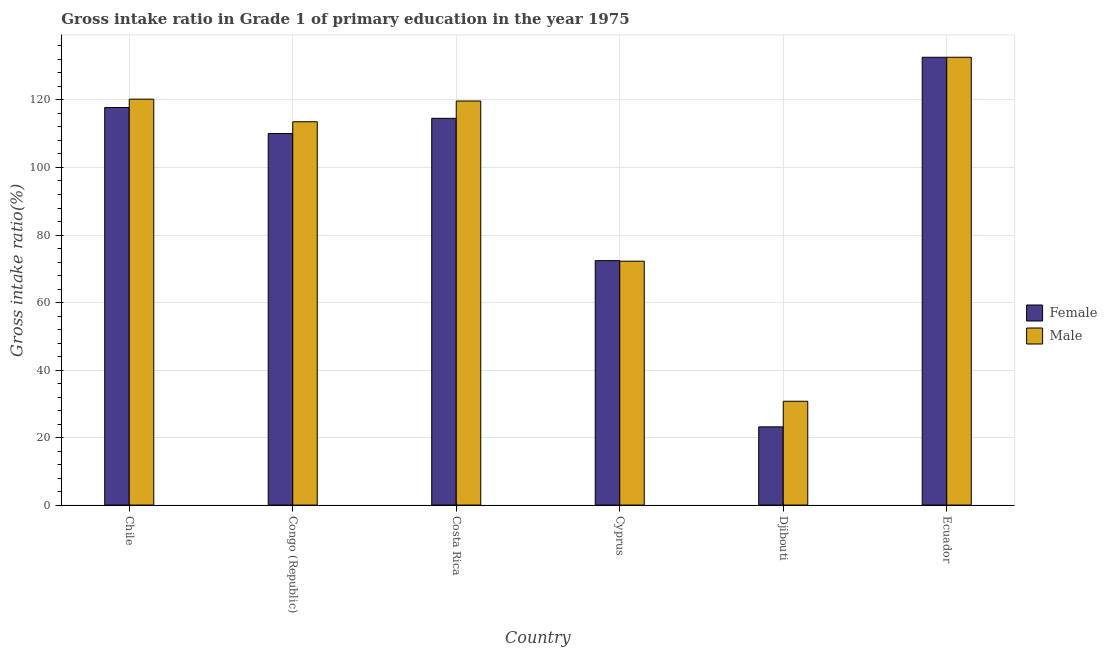How many bars are there on the 4th tick from the left?
Give a very brief answer. 2. How many bars are there on the 3rd tick from the right?
Your answer should be very brief. 2. What is the label of the 6th group of bars from the left?
Give a very brief answer. Ecuador. In how many cases, is the number of bars for a given country not equal to the number of legend labels?
Offer a terse response. 0. What is the gross intake ratio(male) in Djibouti?
Provide a succinct answer. 30.76. Across all countries, what is the maximum gross intake ratio(female)?
Your answer should be compact. 132.65. Across all countries, what is the minimum gross intake ratio(male)?
Offer a very short reply. 30.76. In which country was the gross intake ratio(male) maximum?
Your answer should be compact. Ecuador. In which country was the gross intake ratio(male) minimum?
Provide a short and direct response. Djibouti. What is the total gross intake ratio(male) in the graph?
Keep it short and to the point. 589.14. What is the difference between the gross intake ratio(male) in Chile and that in Congo (Republic)?
Provide a succinct answer. 6.69. What is the difference between the gross intake ratio(male) in Djibouti and the gross intake ratio(female) in Cyprus?
Offer a very short reply. -41.65. What is the average gross intake ratio(male) per country?
Your answer should be very brief. 98.19. What is the difference between the gross intake ratio(male) and gross intake ratio(female) in Ecuador?
Your answer should be compact. 0. In how many countries, is the gross intake ratio(male) greater than 40 %?
Your answer should be very brief. 5. What is the ratio of the gross intake ratio(male) in Cyprus to that in Djibouti?
Offer a terse response. 2.35. What is the difference between the highest and the second highest gross intake ratio(female)?
Keep it short and to the point. 14.89. What is the difference between the highest and the lowest gross intake ratio(male)?
Make the answer very short. 101.9. What does the 1st bar from the left in Djibouti represents?
Your answer should be very brief. Female. What does the 2nd bar from the right in Djibouti represents?
Offer a very short reply. Female. How many bars are there?
Offer a terse response. 12. What is the difference between two consecutive major ticks on the Y-axis?
Your response must be concise. 20. Does the graph contain grids?
Offer a very short reply. Yes. Where does the legend appear in the graph?
Offer a terse response. Center right. How many legend labels are there?
Offer a very short reply. 2. How are the legend labels stacked?
Offer a terse response. Vertical. What is the title of the graph?
Your answer should be compact. Gross intake ratio in Grade 1 of primary education in the year 1975. What is the label or title of the Y-axis?
Give a very brief answer. Gross intake ratio(%). What is the Gross intake ratio(%) of Female in Chile?
Ensure brevity in your answer.  117.76. What is the Gross intake ratio(%) of Male in Chile?
Provide a succinct answer. 120.24. What is the Gross intake ratio(%) of Female in Congo (Republic)?
Your response must be concise. 110.06. What is the Gross intake ratio(%) in Male in Congo (Republic)?
Your response must be concise. 113.55. What is the Gross intake ratio(%) of Female in Costa Rica?
Provide a succinct answer. 114.57. What is the Gross intake ratio(%) of Male in Costa Rica?
Your answer should be very brief. 119.7. What is the Gross intake ratio(%) of Female in Cyprus?
Keep it short and to the point. 72.41. What is the Gross intake ratio(%) of Male in Cyprus?
Provide a succinct answer. 72.24. What is the Gross intake ratio(%) of Female in Djibouti?
Offer a very short reply. 23.17. What is the Gross intake ratio(%) in Male in Djibouti?
Ensure brevity in your answer.  30.76. What is the Gross intake ratio(%) in Female in Ecuador?
Your answer should be compact. 132.65. What is the Gross intake ratio(%) of Male in Ecuador?
Give a very brief answer. 132.65. Across all countries, what is the maximum Gross intake ratio(%) in Female?
Offer a terse response. 132.65. Across all countries, what is the maximum Gross intake ratio(%) of Male?
Offer a very short reply. 132.65. Across all countries, what is the minimum Gross intake ratio(%) in Female?
Keep it short and to the point. 23.17. Across all countries, what is the minimum Gross intake ratio(%) of Male?
Provide a succinct answer. 30.76. What is the total Gross intake ratio(%) of Female in the graph?
Your response must be concise. 570.61. What is the total Gross intake ratio(%) of Male in the graph?
Your answer should be compact. 589.14. What is the difference between the Gross intake ratio(%) of Female in Chile and that in Congo (Republic)?
Offer a terse response. 7.71. What is the difference between the Gross intake ratio(%) in Male in Chile and that in Congo (Republic)?
Your answer should be compact. 6.69. What is the difference between the Gross intake ratio(%) of Female in Chile and that in Costa Rica?
Your response must be concise. 3.2. What is the difference between the Gross intake ratio(%) in Male in Chile and that in Costa Rica?
Ensure brevity in your answer.  0.55. What is the difference between the Gross intake ratio(%) in Female in Chile and that in Cyprus?
Keep it short and to the point. 45.35. What is the difference between the Gross intake ratio(%) of Male in Chile and that in Cyprus?
Your answer should be very brief. 48. What is the difference between the Gross intake ratio(%) in Female in Chile and that in Djibouti?
Make the answer very short. 94.59. What is the difference between the Gross intake ratio(%) of Male in Chile and that in Djibouti?
Give a very brief answer. 89.49. What is the difference between the Gross intake ratio(%) of Female in Chile and that in Ecuador?
Give a very brief answer. -14.89. What is the difference between the Gross intake ratio(%) of Male in Chile and that in Ecuador?
Offer a terse response. -12.41. What is the difference between the Gross intake ratio(%) in Female in Congo (Republic) and that in Costa Rica?
Provide a short and direct response. -4.51. What is the difference between the Gross intake ratio(%) in Male in Congo (Republic) and that in Costa Rica?
Your answer should be very brief. -6.15. What is the difference between the Gross intake ratio(%) in Female in Congo (Republic) and that in Cyprus?
Keep it short and to the point. 37.65. What is the difference between the Gross intake ratio(%) of Male in Congo (Republic) and that in Cyprus?
Keep it short and to the point. 41.31. What is the difference between the Gross intake ratio(%) in Female in Congo (Republic) and that in Djibouti?
Make the answer very short. 86.88. What is the difference between the Gross intake ratio(%) in Male in Congo (Republic) and that in Djibouti?
Your answer should be very brief. 82.79. What is the difference between the Gross intake ratio(%) in Female in Congo (Republic) and that in Ecuador?
Offer a very short reply. -22.59. What is the difference between the Gross intake ratio(%) in Male in Congo (Republic) and that in Ecuador?
Give a very brief answer. -19.1. What is the difference between the Gross intake ratio(%) of Female in Costa Rica and that in Cyprus?
Your answer should be compact. 42.16. What is the difference between the Gross intake ratio(%) in Male in Costa Rica and that in Cyprus?
Offer a terse response. 47.45. What is the difference between the Gross intake ratio(%) of Female in Costa Rica and that in Djibouti?
Your response must be concise. 91.39. What is the difference between the Gross intake ratio(%) in Male in Costa Rica and that in Djibouti?
Your response must be concise. 88.94. What is the difference between the Gross intake ratio(%) of Female in Costa Rica and that in Ecuador?
Offer a very short reply. -18.08. What is the difference between the Gross intake ratio(%) of Male in Costa Rica and that in Ecuador?
Keep it short and to the point. -12.96. What is the difference between the Gross intake ratio(%) in Female in Cyprus and that in Djibouti?
Offer a very short reply. 49.24. What is the difference between the Gross intake ratio(%) of Male in Cyprus and that in Djibouti?
Offer a very short reply. 41.49. What is the difference between the Gross intake ratio(%) in Female in Cyprus and that in Ecuador?
Offer a terse response. -60.24. What is the difference between the Gross intake ratio(%) in Male in Cyprus and that in Ecuador?
Make the answer very short. -60.41. What is the difference between the Gross intake ratio(%) of Female in Djibouti and that in Ecuador?
Offer a very short reply. -109.48. What is the difference between the Gross intake ratio(%) of Male in Djibouti and that in Ecuador?
Your answer should be compact. -101.9. What is the difference between the Gross intake ratio(%) in Female in Chile and the Gross intake ratio(%) in Male in Congo (Republic)?
Provide a short and direct response. 4.21. What is the difference between the Gross intake ratio(%) of Female in Chile and the Gross intake ratio(%) of Male in Costa Rica?
Your response must be concise. -1.93. What is the difference between the Gross intake ratio(%) in Female in Chile and the Gross intake ratio(%) in Male in Cyprus?
Offer a very short reply. 45.52. What is the difference between the Gross intake ratio(%) of Female in Chile and the Gross intake ratio(%) of Male in Djibouti?
Your answer should be compact. 87.01. What is the difference between the Gross intake ratio(%) of Female in Chile and the Gross intake ratio(%) of Male in Ecuador?
Make the answer very short. -14.89. What is the difference between the Gross intake ratio(%) in Female in Congo (Republic) and the Gross intake ratio(%) in Male in Costa Rica?
Keep it short and to the point. -9.64. What is the difference between the Gross intake ratio(%) of Female in Congo (Republic) and the Gross intake ratio(%) of Male in Cyprus?
Ensure brevity in your answer.  37.81. What is the difference between the Gross intake ratio(%) of Female in Congo (Republic) and the Gross intake ratio(%) of Male in Djibouti?
Your answer should be very brief. 79.3. What is the difference between the Gross intake ratio(%) in Female in Congo (Republic) and the Gross intake ratio(%) in Male in Ecuador?
Offer a terse response. -22.6. What is the difference between the Gross intake ratio(%) of Female in Costa Rica and the Gross intake ratio(%) of Male in Cyprus?
Ensure brevity in your answer.  42.32. What is the difference between the Gross intake ratio(%) of Female in Costa Rica and the Gross intake ratio(%) of Male in Djibouti?
Your answer should be compact. 83.81. What is the difference between the Gross intake ratio(%) in Female in Costa Rica and the Gross intake ratio(%) in Male in Ecuador?
Your response must be concise. -18.09. What is the difference between the Gross intake ratio(%) in Female in Cyprus and the Gross intake ratio(%) in Male in Djibouti?
Your answer should be very brief. 41.65. What is the difference between the Gross intake ratio(%) in Female in Cyprus and the Gross intake ratio(%) in Male in Ecuador?
Offer a terse response. -60.24. What is the difference between the Gross intake ratio(%) of Female in Djibouti and the Gross intake ratio(%) of Male in Ecuador?
Your answer should be compact. -109.48. What is the average Gross intake ratio(%) of Female per country?
Keep it short and to the point. 95.1. What is the average Gross intake ratio(%) in Male per country?
Offer a terse response. 98.19. What is the difference between the Gross intake ratio(%) of Female and Gross intake ratio(%) of Male in Chile?
Offer a terse response. -2.48. What is the difference between the Gross intake ratio(%) of Female and Gross intake ratio(%) of Male in Congo (Republic)?
Offer a very short reply. -3.49. What is the difference between the Gross intake ratio(%) of Female and Gross intake ratio(%) of Male in Costa Rica?
Ensure brevity in your answer.  -5.13. What is the difference between the Gross intake ratio(%) of Female and Gross intake ratio(%) of Male in Cyprus?
Your answer should be compact. 0.17. What is the difference between the Gross intake ratio(%) in Female and Gross intake ratio(%) in Male in Djibouti?
Your answer should be compact. -7.58. What is the difference between the Gross intake ratio(%) of Female and Gross intake ratio(%) of Male in Ecuador?
Offer a very short reply. -0. What is the ratio of the Gross intake ratio(%) in Female in Chile to that in Congo (Republic)?
Keep it short and to the point. 1.07. What is the ratio of the Gross intake ratio(%) in Male in Chile to that in Congo (Republic)?
Ensure brevity in your answer.  1.06. What is the ratio of the Gross intake ratio(%) in Female in Chile to that in Costa Rica?
Offer a terse response. 1.03. What is the ratio of the Gross intake ratio(%) in Male in Chile to that in Costa Rica?
Your answer should be very brief. 1. What is the ratio of the Gross intake ratio(%) of Female in Chile to that in Cyprus?
Offer a terse response. 1.63. What is the ratio of the Gross intake ratio(%) of Male in Chile to that in Cyprus?
Your response must be concise. 1.66. What is the ratio of the Gross intake ratio(%) in Female in Chile to that in Djibouti?
Provide a short and direct response. 5.08. What is the ratio of the Gross intake ratio(%) of Male in Chile to that in Djibouti?
Offer a terse response. 3.91. What is the ratio of the Gross intake ratio(%) of Female in Chile to that in Ecuador?
Offer a very short reply. 0.89. What is the ratio of the Gross intake ratio(%) in Male in Chile to that in Ecuador?
Provide a short and direct response. 0.91. What is the ratio of the Gross intake ratio(%) of Female in Congo (Republic) to that in Costa Rica?
Make the answer very short. 0.96. What is the ratio of the Gross intake ratio(%) in Male in Congo (Republic) to that in Costa Rica?
Give a very brief answer. 0.95. What is the ratio of the Gross intake ratio(%) of Female in Congo (Republic) to that in Cyprus?
Offer a very short reply. 1.52. What is the ratio of the Gross intake ratio(%) in Male in Congo (Republic) to that in Cyprus?
Provide a succinct answer. 1.57. What is the ratio of the Gross intake ratio(%) in Female in Congo (Republic) to that in Djibouti?
Your response must be concise. 4.75. What is the ratio of the Gross intake ratio(%) of Male in Congo (Republic) to that in Djibouti?
Keep it short and to the point. 3.69. What is the ratio of the Gross intake ratio(%) of Female in Congo (Republic) to that in Ecuador?
Make the answer very short. 0.83. What is the ratio of the Gross intake ratio(%) of Male in Congo (Republic) to that in Ecuador?
Provide a short and direct response. 0.86. What is the ratio of the Gross intake ratio(%) of Female in Costa Rica to that in Cyprus?
Keep it short and to the point. 1.58. What is the ratio of the Gross intake ratio(%) of Male in Costa Rica to that in Cyprus?
Your answer should be compact. 1.66. What is the ratio of the Gross intake ratio(%) in Female in Costa Rica to that in Djibouti?
Offer a terse response. 4.94. What is the ratio of the Gross intake ratio(%) in Male in Costa Rica to that in Djibouti?
Your answer should be very brief. 3.89. What is the ratio of the Gross intake ratio(%) in Female in Costa Rica to that in Ecuador?
Offer a very short reply. 0.86. What is the ratio of the Gross intake ratio(%) in Male in Costa Rica to that in Ecuador?
Your response must be concise. 0.9. What is the ratio of the Gross intake ratio(%) in Female in Cyprus to that in Djibouti?
Give a very brief answer. 3.12. What is the ratio of the Gross intake ratio(%) in Male in Cyprus to that in Djibouti?
Offer a terse response. 2.35. What is the ratio of the Gross intake ratio(%) in Female in Cyprus to that in Ecuador?
Provide a short and direct response. 0.55. What is the ratio of the Gross intake ratio(%) in Male in Cyprus to that in Ecuador?
Your answer should be very brief. 0.54. What is the ratio of the Gross intake ratio(%) in Female in Djibouti to that in Ecuador?
Ensure brevity in your answer.  0.17. What is the ratio of the Gross intake ratio(%) in Male in Djibouti to that in Ecuador?
Provide a short and direct response. 0.23. What is the difference between the highest and the second highest Gross intake ratio(%) of Female?
Keep it short and to the point. 14.89. What is the difference between the highest and the second highest Gross intake ratio(%) in Male?
Give a very brief answer. 12.41. What is the difference between the highest and the lowest Gross intake ratio(%) in Female?
Your answer should be very brief. 109.48. What is the difference between the highest and the lowest Gross intake ratio(%) in Male?
Provide a succinct answer. 101.9. 